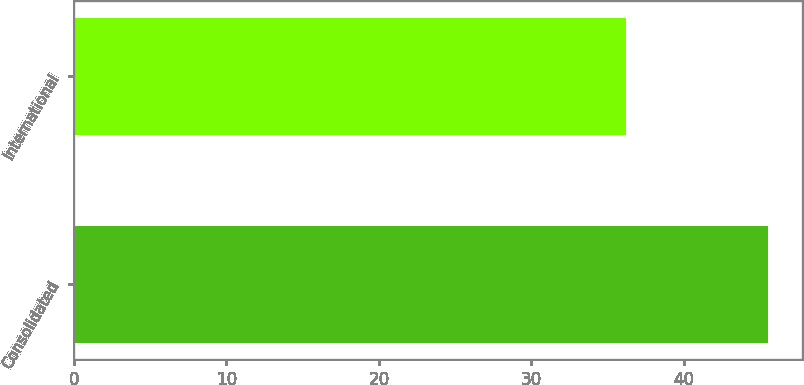<chart> <loc_0><loc_0><loc_500><loc_500><bar_chart><fcel>Consolidated<fcel>International<nl><fcel>45.5<fcel>36.2<nl></chart> 